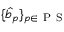<formula> <loc_0><loc_0><loc_500><loc_500>\{ \hat { b } _ { p } \} _ { p \in { P S } }</formula> 